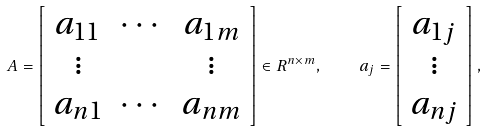Convert formula to latex. <formula><loc_0><loc_0><loc_500><loc_500>A = \left [ \begin{array} { c c c } a _ { 1 1 } & \cdots & a _ { 1 m } \\ \vdots & & \vdots \\ a _ { n 1 } & \cdots & a _ { n m } \\ \end{array} \right ] \in R ^ { n \times m } , \quad a _ { j } = \left [ \begin{array} { c } a _ { 1 j } \\ \vdots \\ a _ { n j } \\ \end{array} \right ] ,</formula> 